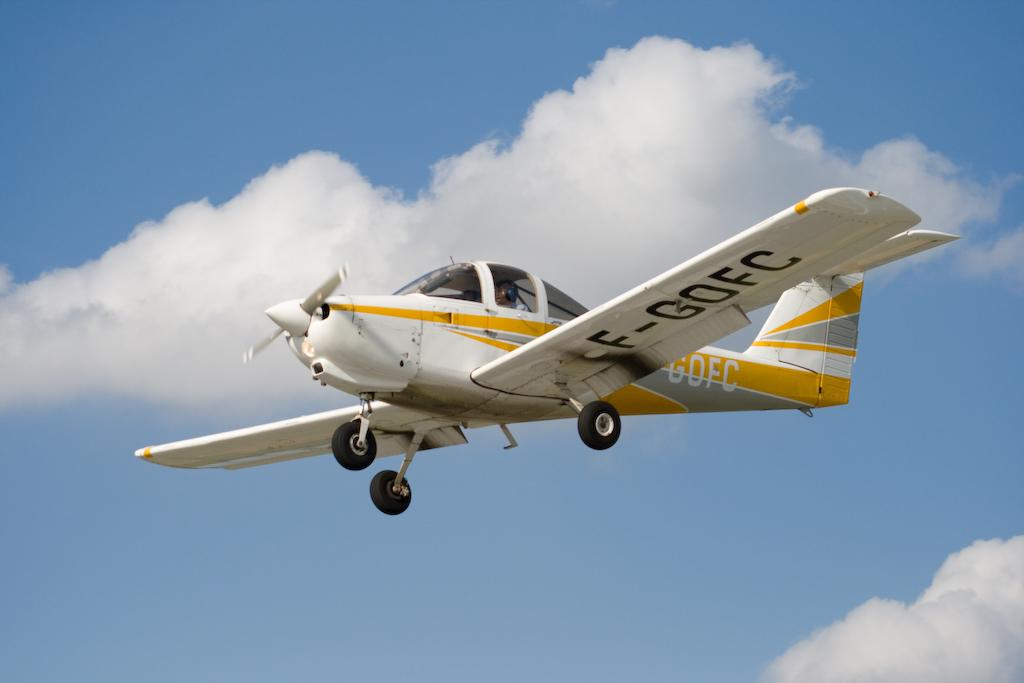<image>
Offer a succinct explanation of the picture presented. the word GOFC is on the back of a plane 